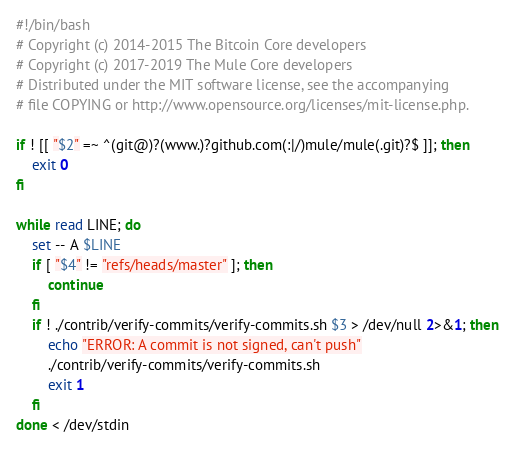<code> <loc_0><loc_0><loc_500><loc_500><_Bash_>#!/bin/bash
# Copyright (c) 2014-2015 The Bitcoin Core developers
# Copyright (c) 2017-2019 The Mule Core developers
# Distributed under the MIT software license, see the accompanying
# file COPYING or http://www.opensource.org/licenses/mit-license.php.

if ! [[ "$2" =~ ^(git@)?(www.)?github.com(:|/)mule/mule(.git)?$ ]]; then
    exit 0
fi

while read LINE; do
    set -- A $LINE
    if [ "$4" != "refs/heads/master" ]; then
        continue
    fi
    if ! ./contrib/verify-commits/verify-commits.sh $3 > /dev/null 2>&1; then
        echo "ERROR: A commit is not signed, can't push"
        ./contrib/verify-commits/verify-commits.sh
        exit 1
    fi
done < /dev/stdin
</code> 